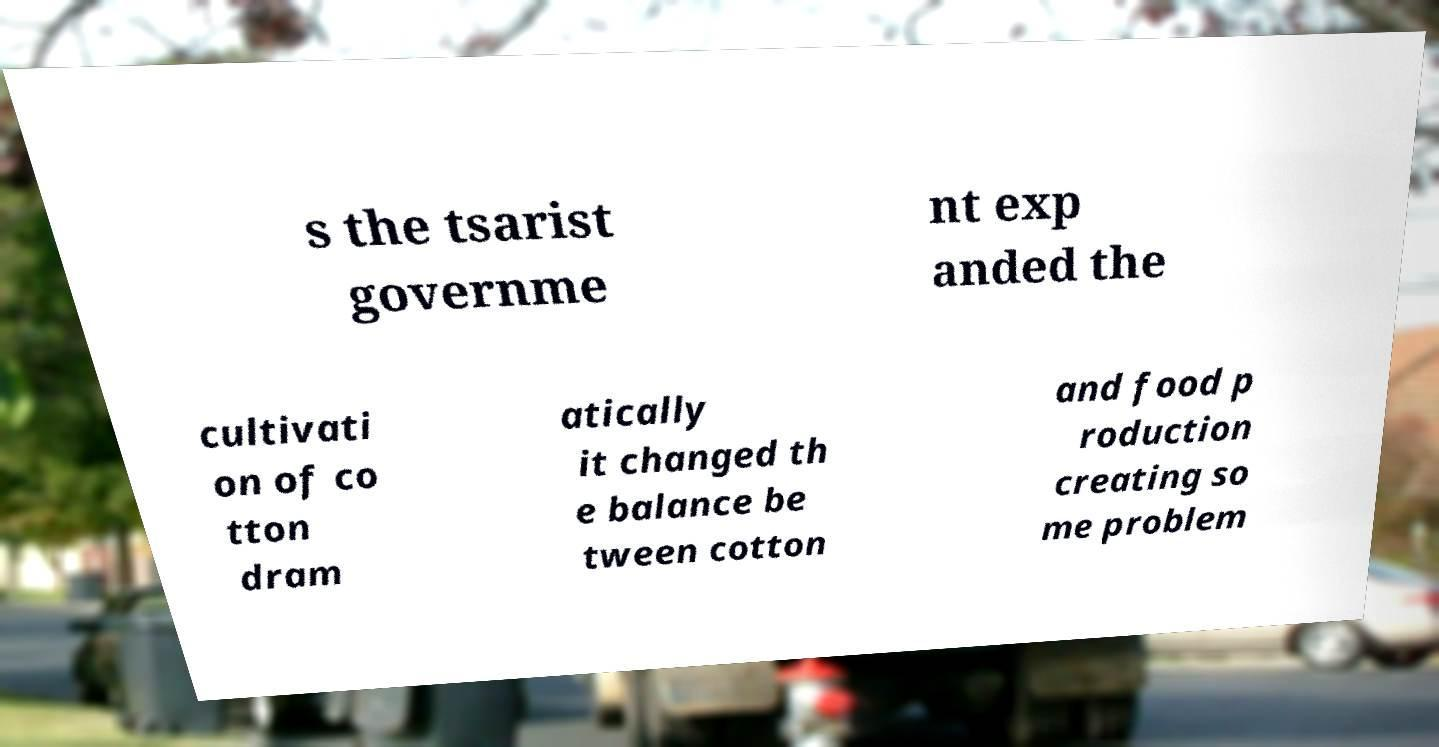Could you assist in decoding the text presented in this image and type it out clearly? s the tsarist governme nt exp anded the cultivati on of co tton dram atically it changed th e balance be tween cotton and food p roduction creating so me problem 